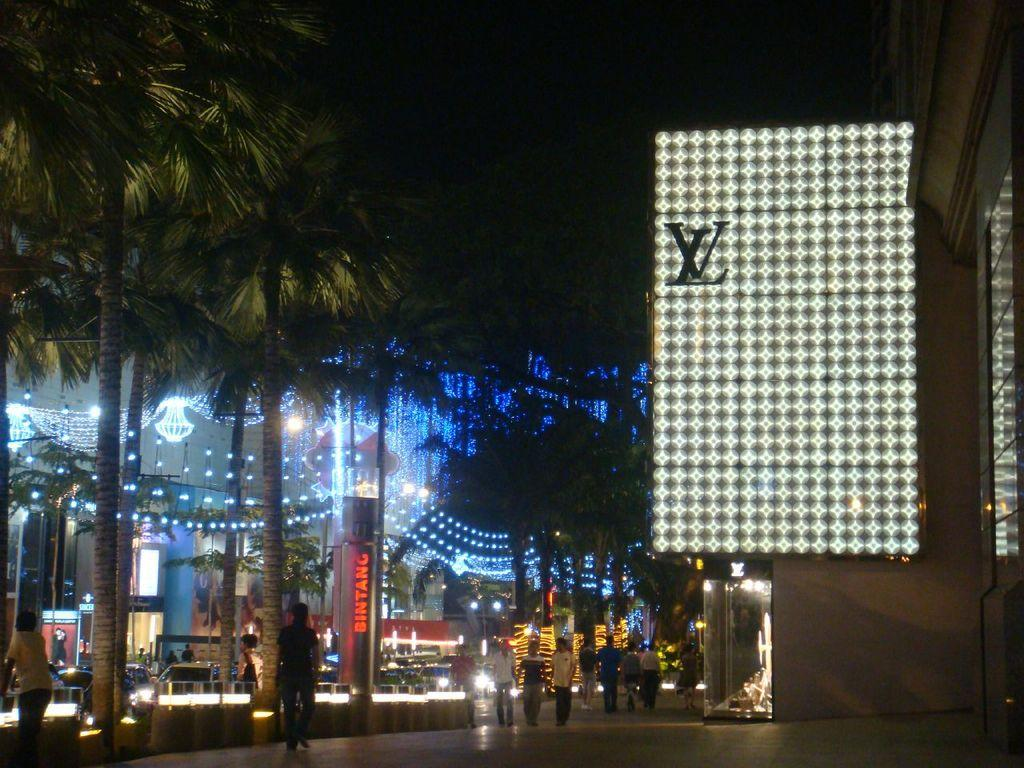What is located on the right side of the image? There is a screen and a building on the right side of the image. What type of vegetation is on the left side of the image? There are trees on the left side of the image. What can be seen happening on the left side of the image? There are persons walking on the road on the left side of the image. What is visible in the image that might provide illumination? There are lights visible in the image. Can you tell me how many deer are present in the bedroom in the image? There is no bedroom or deer present in the image. What type of cord is connected to the screen in the image? There is no cord connected to the screen in the image. 